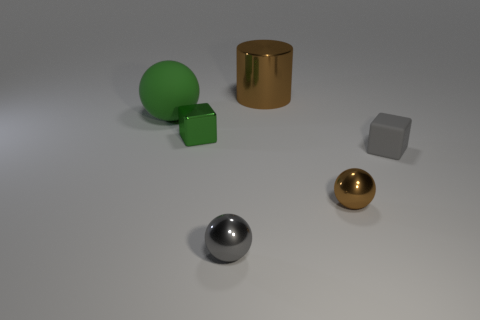Is there a metal block that has the same color as the big rubber ball?
Keep it short and to the point. Yes. What shape is the brown shiny object that is the same size as the matte sphere?
Offer a terse response. Cylinder. There is a cube that is left of the tiny gray cube; what color is it?
Provide a succinct answer. Green. There is a tiny cube on the right side of the tiny brown thing; are there any tiny blocks to the left of it?
Make the answer very short. Yes. How many things are brown objects that are behind the tiny green block or large balls?
Offer a terse response. 2. There is a large object that is right of the ball behind the green cube; what is it made of?
Ensure brevity in your answer.  Metal. Are there an equal number of cubes that are to the right of the green metal thing and matte things that are right of the large metallic cylinder?
Your answer should be very brief. Yes. How many objects are either tiny gray objects behind the gray sphere or tiny metal things that are to the left of the big brown metallic cylinder?
Your response must be concise. 3. There is a object that is both behind the tiny gray cube and in front of the big matte sphere; what is its material?
Keep it short and to the point. Metal. There is a brown metallic thing in front of the tiny block that is left of the metallic object that is behind the small green metal thing; what is its size?
Ensure brevity in your answer.  Small. 